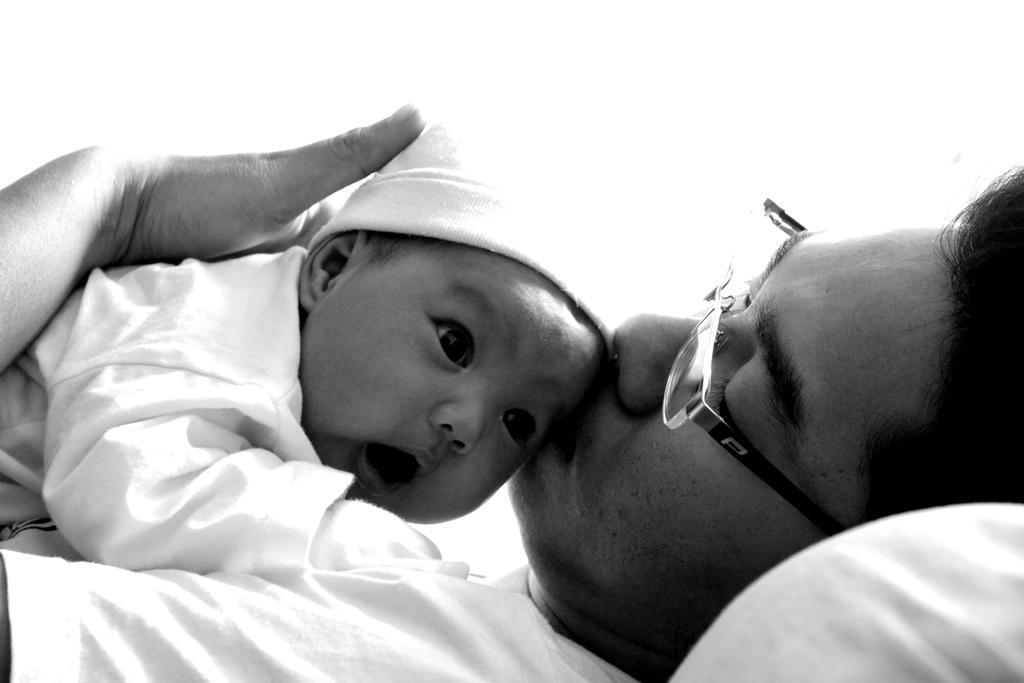Describe this image in one or two sentences. This is a black and white image. In this image we can see a person holding a baby and kissing.   